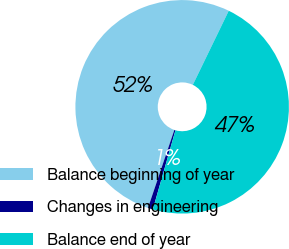Convert chart. <chart><loc_0><loc_0><loc_500><loc_500><pie_chart><fcel>Balance beginning of year<fcel>Changes in engineering<fcel>Balance end of year<nl><fcel>52.0%<fcel>0.76%<fcel>47.24%<nl></chart> 